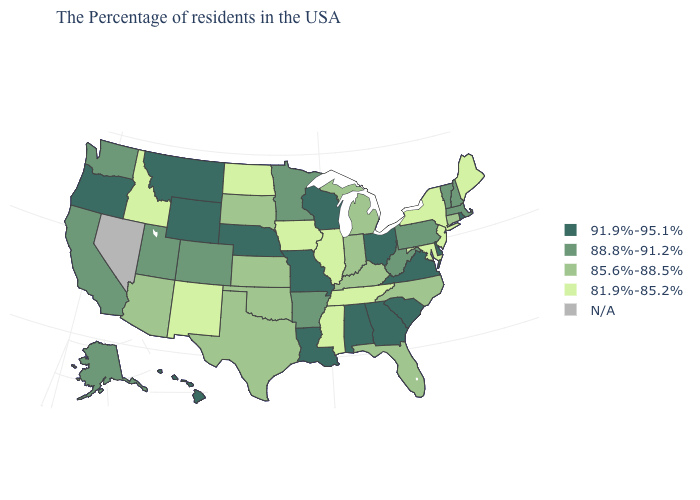Does Delaware have the highest value in the South?
Concise answer only. Yes. What is the highest value in the USA?
Quick response, please. 91.9%-95.1%. Does the first symbol in the legend represent the smallest category?
Write a very short answer. No. Does Iowa have the lowest value in the USA?
Short answer required. Yes. What is the value of Vermont?
Quick response, please. 88.8%-91.2%. Name the states that have a value in the range 88.8%-91.2%?
Short answer required. Massachusetts, New Hampshire, Vermont, Pennsylvania, West Virginia, Arkansas, Minnesota, Colorado, Utah, California, Washington, Alaska. What is the value of Nebraska?
Write a very short answer. 91.9%-95.1%. What is the value of Kentucky?
Be succinct. 85.6%-88.5%. Does Washington have the highest value in the USA?
Give a very brief answer. No. What is the value of Georgia?
Be succinct. 91.9%-95.1%. Which states hav the highest value in the MidWest?
Answer briefly. Ohio, Wisconsin, Missouri, Nebraska. What is the value of Massachusetts?
Write a very short answer. 88.8%-91.2%. What is the value of Virginia?
Be succinct. 91.9%-95.1%. What is the lowest value in the USA?
Be succinct. 81.9%-85.2%. 